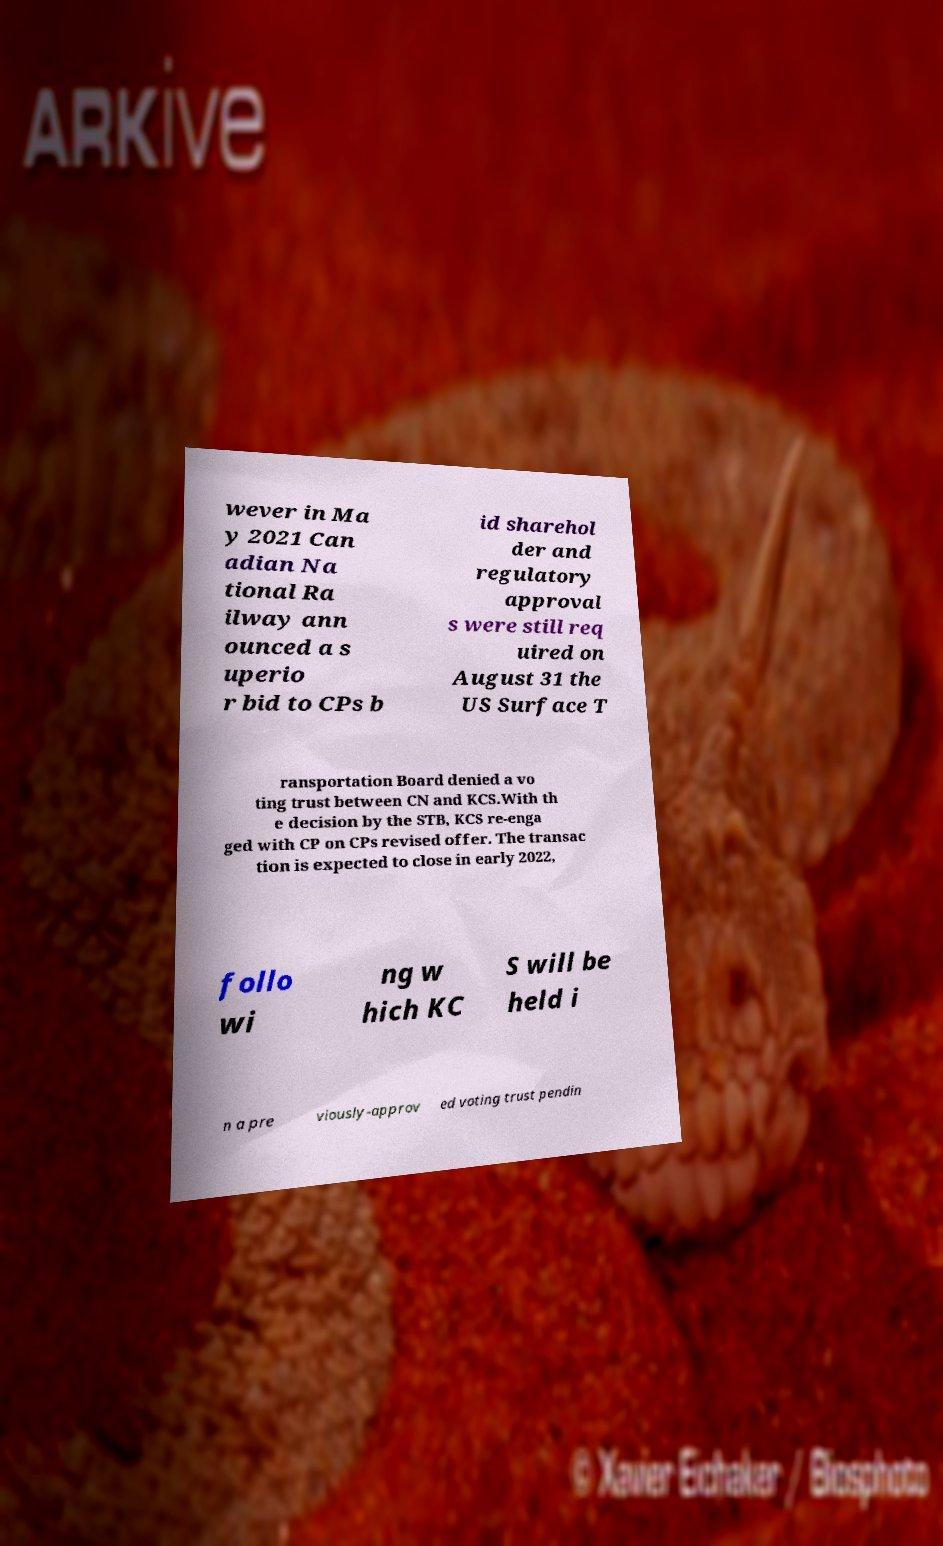What messages or text are displayed in this image? I need them in a readable, typed format. wever in Ma y 2021 Can adian Na tional Ra ilway ann ounced a s uperio r bid to CPs b id sharehol der and regulatory approval s were still req uired on August 31 the US Surface T ransportation Board denied a vo ting trust between CN and KCS.With th e decision by the STB, KCS re-enga ged with CP on CPs revised offer. The transac tion is expected to close in early 2022, follo wi ng w hich KC S will be held i n a pre viously-approv ed voting trust pendin 